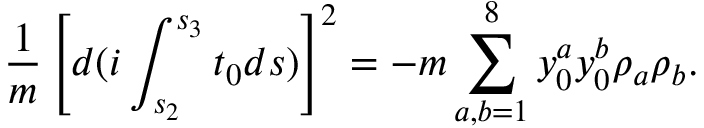<formula> <loc_0><loc_0><loc_500><loc_500>\frac { 1 } { m } \left [ d ( i \int _ { s _ { 2 } } ^ { s _ { 3 } } t _ { 0 } d s ) \right ] ^ { 2 } = - m \sum _ { a , b = 1 } ^ { 8 } { y } _ { 0 } ^ { a } { y } _ { 0 } ^ { b } \rho _ { a } \rho _ { b } .</formula> 